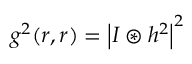Convert formula to latex. <formula><loc_0><loc_0><loc_500><loc_500>g ^ { 2 } ( r , r ) = \left | I \circledast h ^ { 2 } \right | ^ { 2 }</formula> 